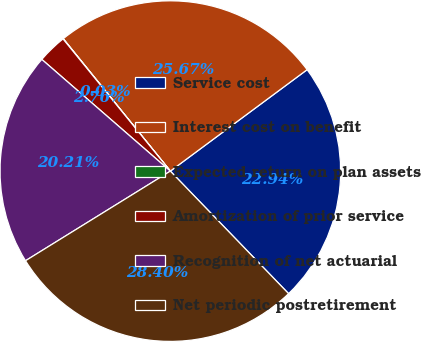Convert chart. <chart><loc_0><loc_0><loc_500><loc_500><pie_chart><fcel>Service cost<fcel>Interest cost on benefit<fcel>Expected return on plan assets<fcel>Amortization of prior service<fcel>Recognition of net actuarial<fcel>Net periodic postretirement<nl><fcel>22.94%<fcel>25.67%<fcel>0.03%<fcel>2.76%<fcel>20.21%<fcel>28.4%<nl></chart> 